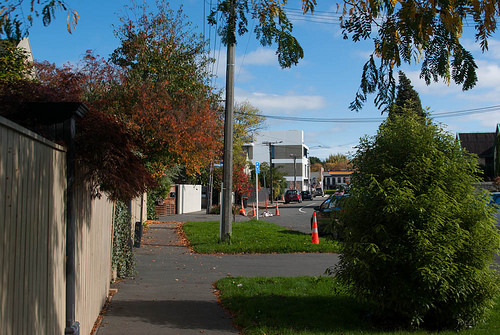<image>
Can you confirm if the traffic cone is to the right of the sidewalk? Yes. From this viewpoint, the traffic cone is positioned to the right side relative to the sidewalk. 